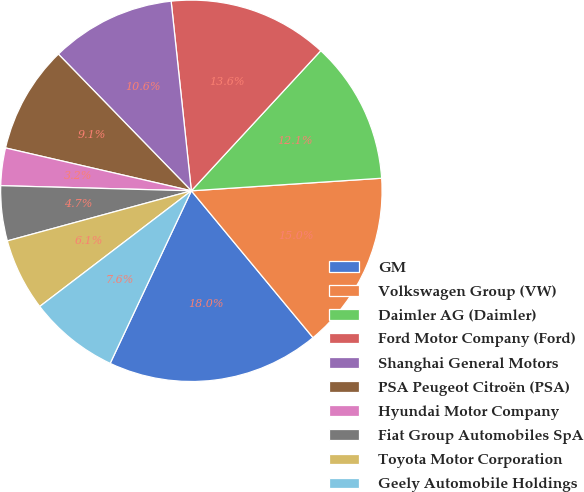Convert chart. <chart><loc_0><loc_0><loc_500><loc_500><pie_chart><fcel>GM<fcel>Volkswagen Group (VW)<fcel>Daimler AG (Daimler)<fcel>Ford Motor Company (Ford)<fcel>Shanghai General Motors<fcel>PSA Peugeot Citroën (PSA)<fcel>Hyundai Motor Company<fcel>Fiat Group Automobiles SpA<fcel>Toyota Motor Corporation<fcel>Geely Automobile Holdings<nl><fcel>18.01%<fcel>15.04%<fcel>12.08%<fcel>13.56%<fcel>10.59%<fcel>9.11%<fcel>3.18%<fcel>4.66%<fcel>6.14%<fcel>7.63%<nl></chart> 